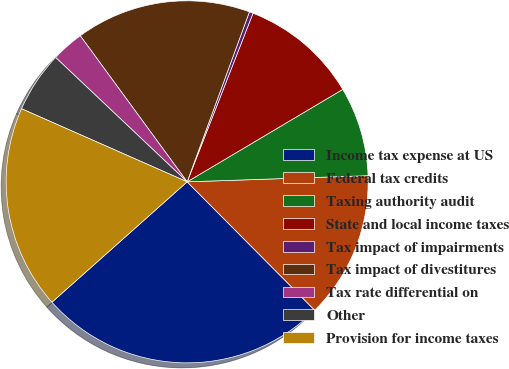Convert chart. <chart><loc_0><loc_0><loc_500><loc_500><pie_chart><fcel>Income tax expense at US<fcel>Federal tax credits<fcel>Taxing authority audit<fcel>State and local income taxes<fcel>Tax impact of impairments<fcel>Tax impact of divestitures<fcel>Tax rate differential on<fcel>Other<fcel>Provision for income taxes<nl><fcel>25.87%<fcel>13.09%<fcel>7.99%<fcel>10.54%<fcel>0.34%<fcel>15.64%<fcel>2.89%<fcel>5.44%<fcel>18.19%<nl></chart> 